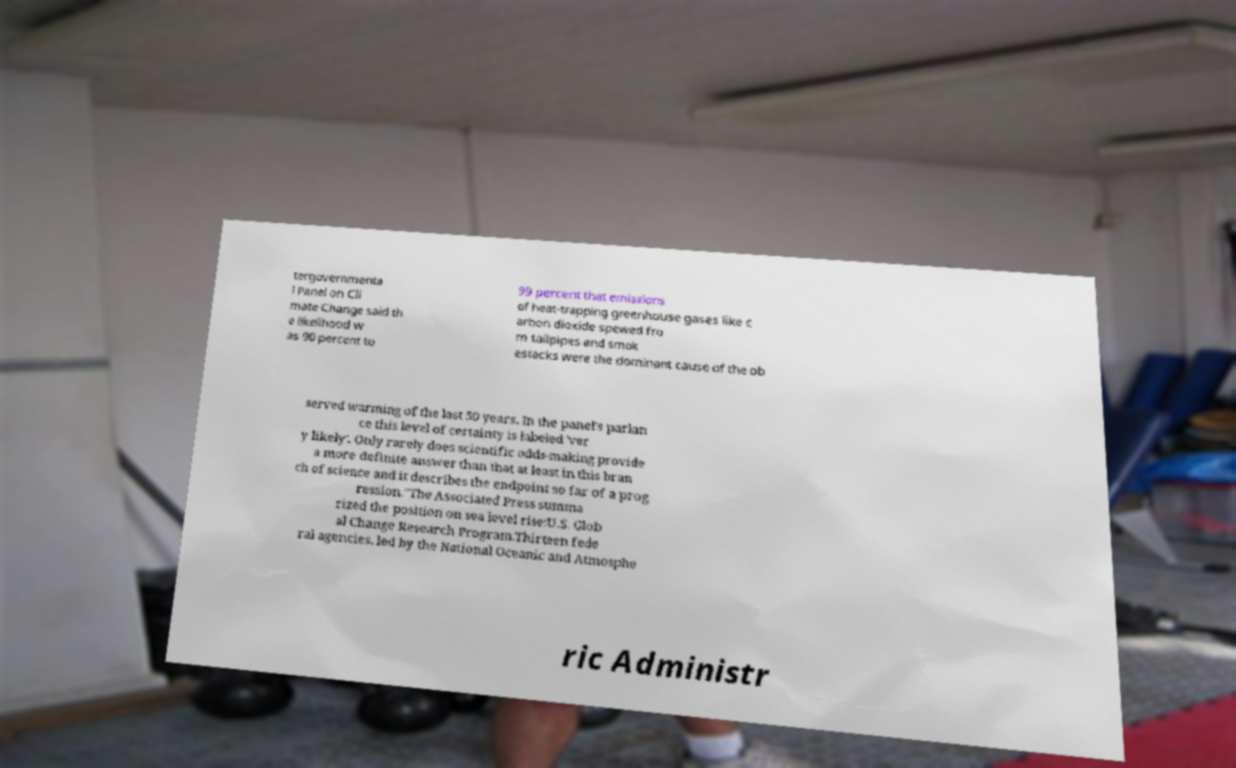Can you accurately transcribe the text from the provided image for me? tergovernmenta l Panel on Cli mate Change said th e likelihood w as 90 percent to 99 percent that emissions of heat-trapping greenhouse gases like c arbon dioxide spewed fro m tailpipes and smok estacks were the dominant cause of the ob served warming of the last 50 years. In the panel's parlan ce this level of certainty is labeled 'ver y likely'. Only rarely does scientific odds-making provide a more definite answer than that at least in this bran ch of science and it describes the endpoint so far of a prog ression."The Associated Press summa rized the position on sea level rise:U.S. Glob al Change Research Program.Thirteen fede ral agencies, led by the National Oceanic and Atmosphe ric Administr 